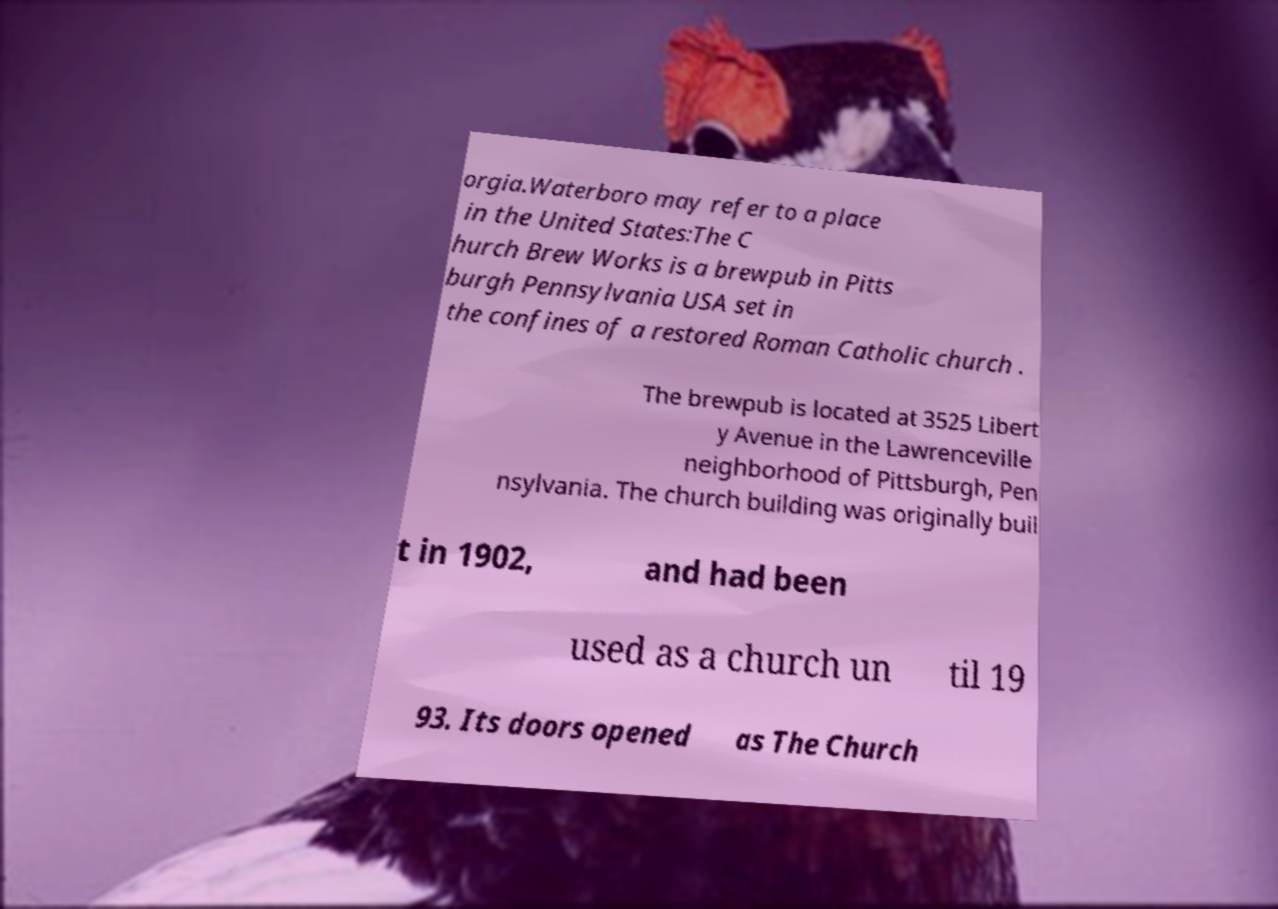Can you read and provide the text displayed in the image?This photo seems to have some interesting text. Can you extract and type it out for me? orgia.Waterboro may refer to a place in the United States:The C hurch Brew Works is a brewpub in Pitts burgh Pennsylvania USA set in the confines of a restored Roman Catholic church . The brewpub is located at 3525 Libert y Avenue in the Lawrenceville neighborhood of Pittsburgh, Pen nsylvania. The church building was originally buil t in 1902, and had been used as a church un til 19 93. Its doors opened as The Church 